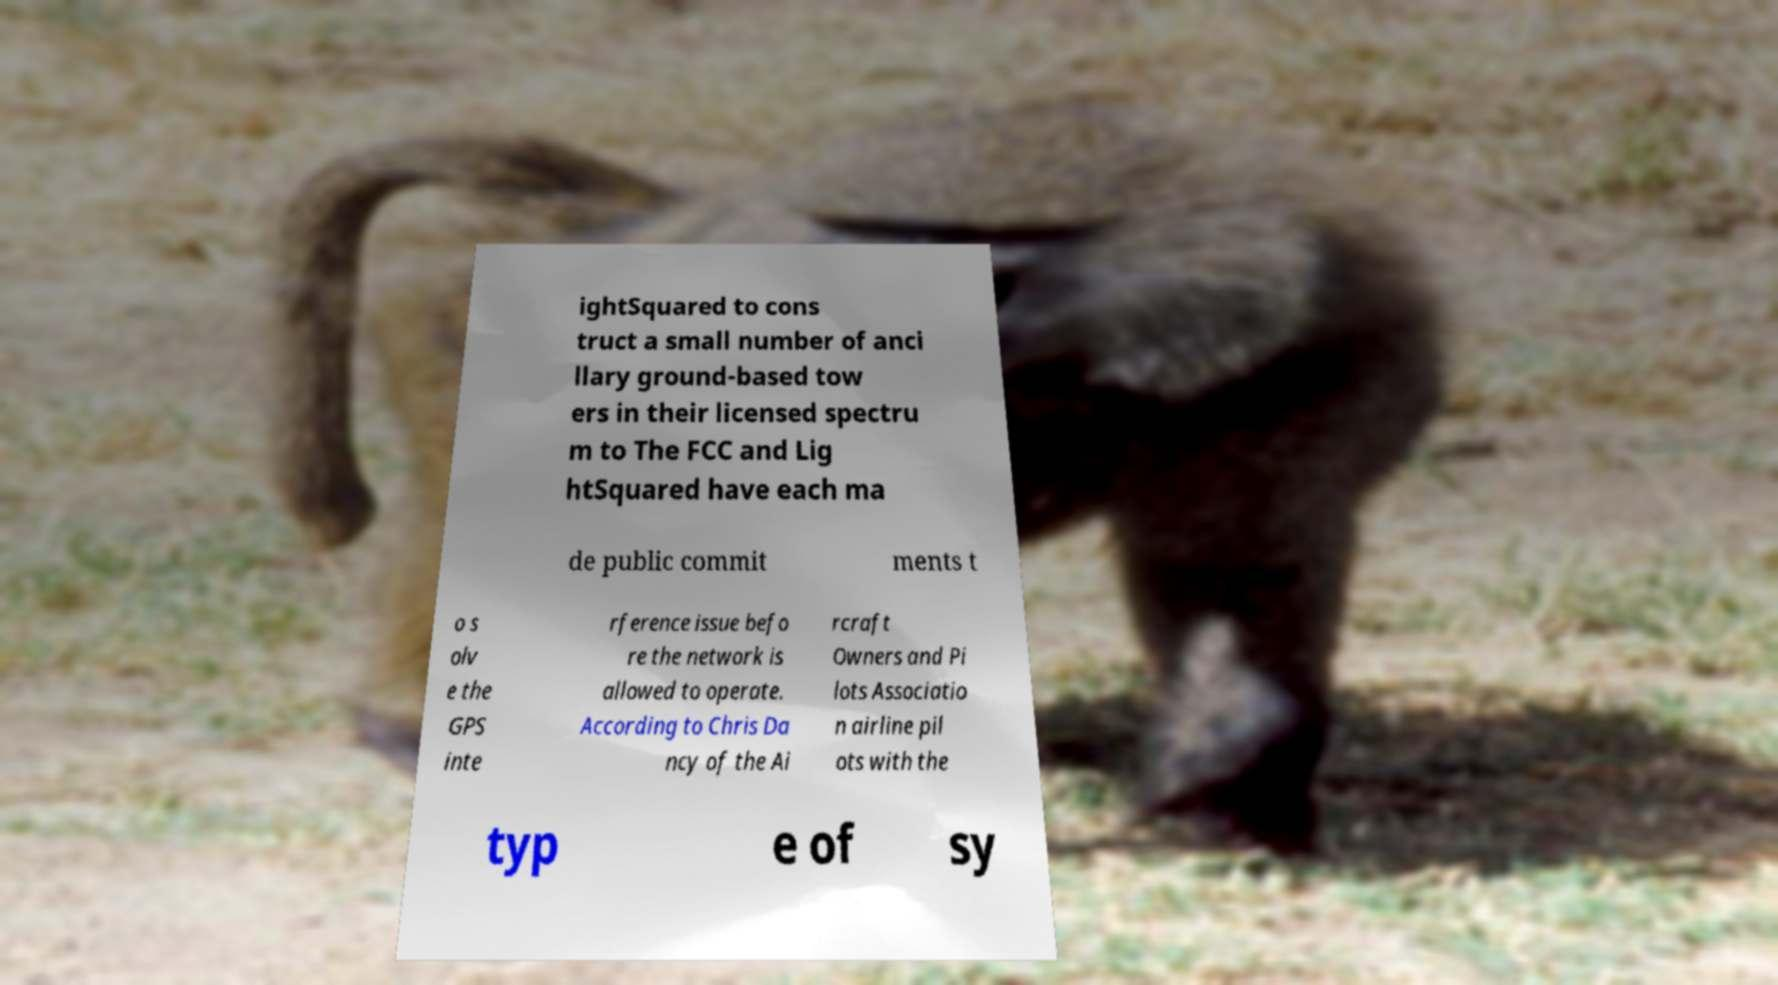Could you assist in decoding the text presented in this image and type it out clearly? ightSquared to cons truct a small number of anci llary ground-based tow ers in their licensed spectru m to The FCC and Lig htSquared have each ma de public commit ments t o s olv e the GPS inte rference issue befo re the network is allowed to operate. According to Chris Da ncy of the Ai rcraft Owners and Pi lots Associatio n airline pil ots with the typ e of sy 